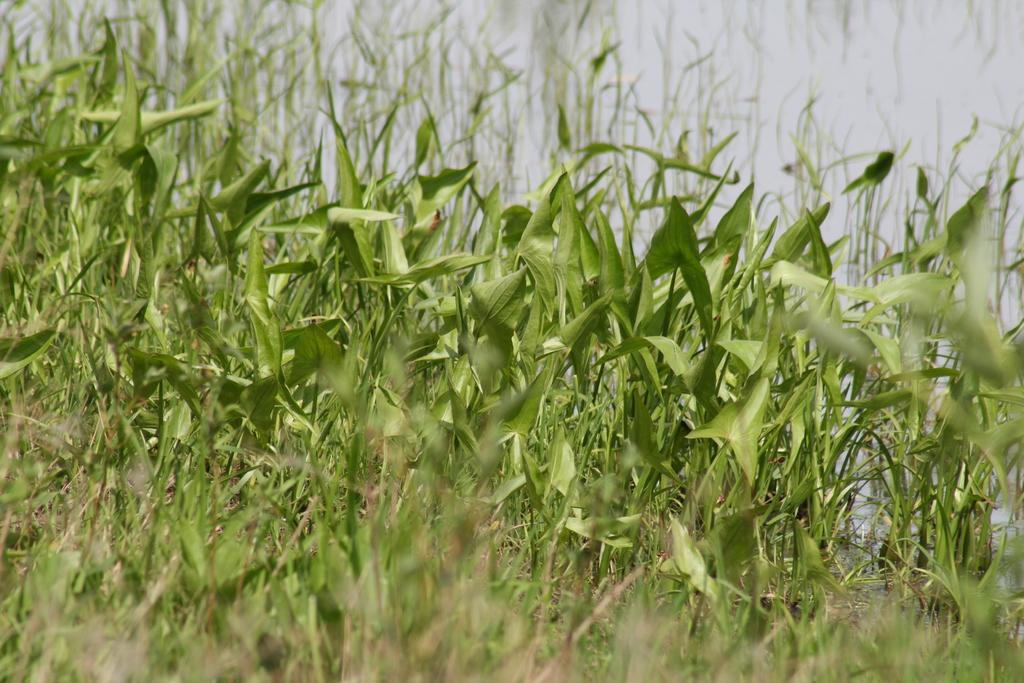How would you summarize this image in a sentence or two? In this picture I can see the bushes in the middle, at the top there is the sky. 